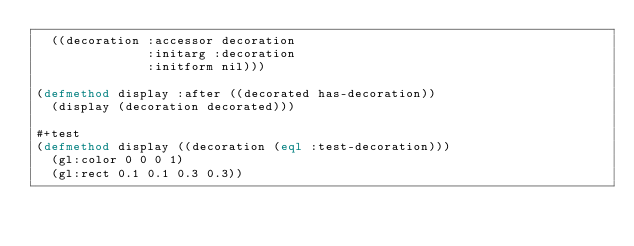Convert code to text. <code><loc_0><loc_0><loc_500><loc_500><_Lisp_>  ((decoration :accessor decoration
               :initarg :decoration
               :initform nil)))

(defmethod display :after ((decorated has-decoration))
  (display (decoration decorated)))

#+test
(defmethod display ((decoration (eql :test-decoration)))
  (gl:color 0 0 0 1)
  (gl:rect 0.1 0.1 0.3 0.3))

</code> 